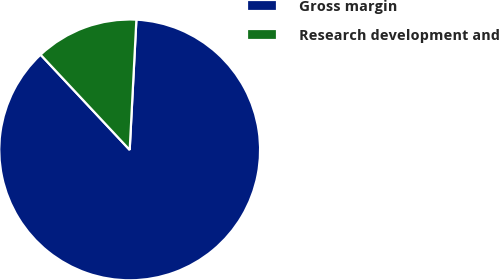Convert chart. <chart><loc_0><loc_0><loc_500><loc_500><pie_chart><fcel>Gross margin<fcel>Research development and<nl><fcel>87.21%<fcel>12.79%<nl></chart> 